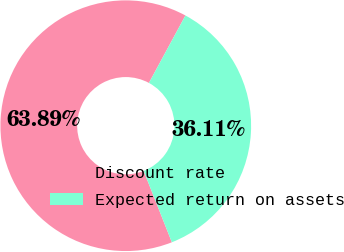<chart> <loc_0><loc_0><loc_500><loc_500><pie_chart><fcel>Discount rate<fcel>Expected return on assets<nl><fcel>63.89%<fcel>36.11%<nl></chart> 